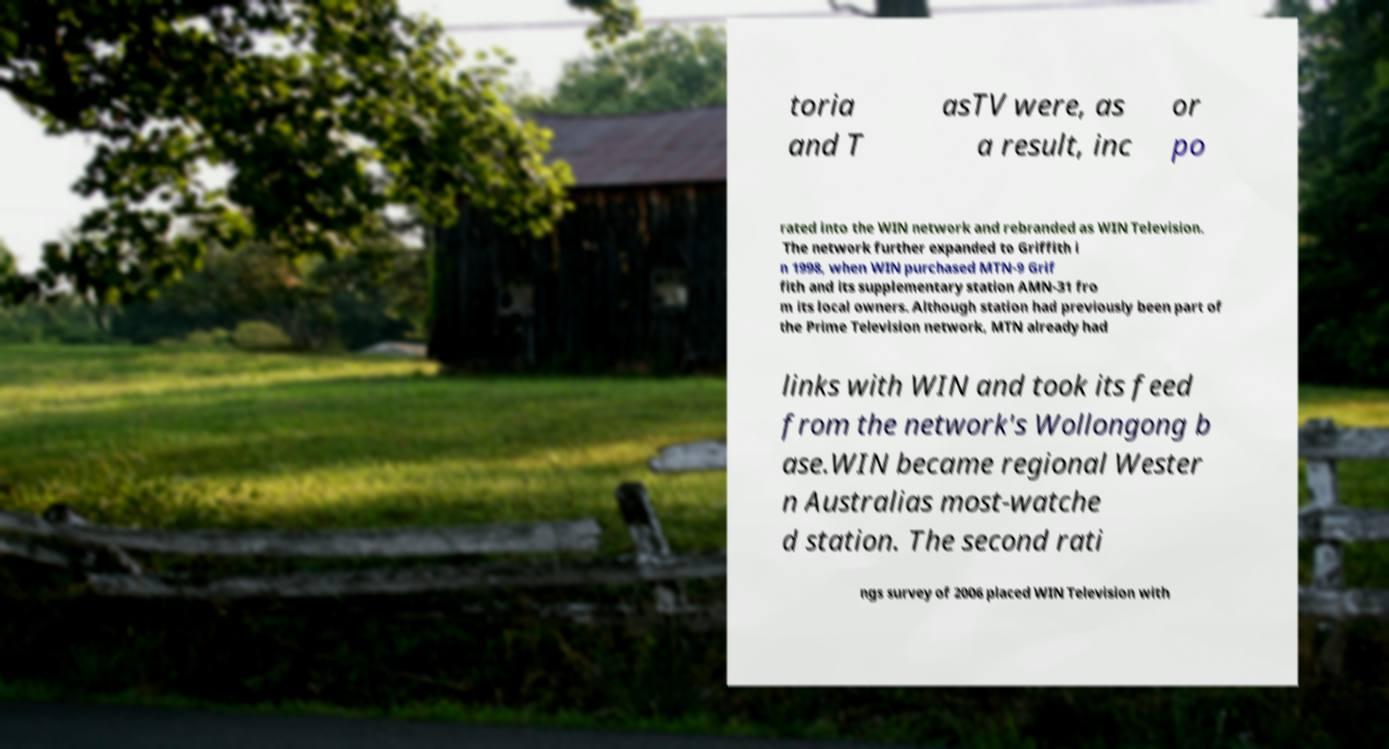Can you accurately transcribe the text from the provided image for me? toria and T asTV were, as a result, inc or po rated into the WIN network and rebranded as WIN Television. The network further expanded to Griffith i n 1998, when WIN purchased MTN-9 Grif fith and its supplementary station AMN-31 fro m its local owners. Although station had previously been part of the Prime Television network, MTN already had links with WIN and took its feed from the network's Wollongong b ase.WIN became regional Wester n Australias most-watche d station. The second rati ngs survey of 2006 placed WIN Television with 